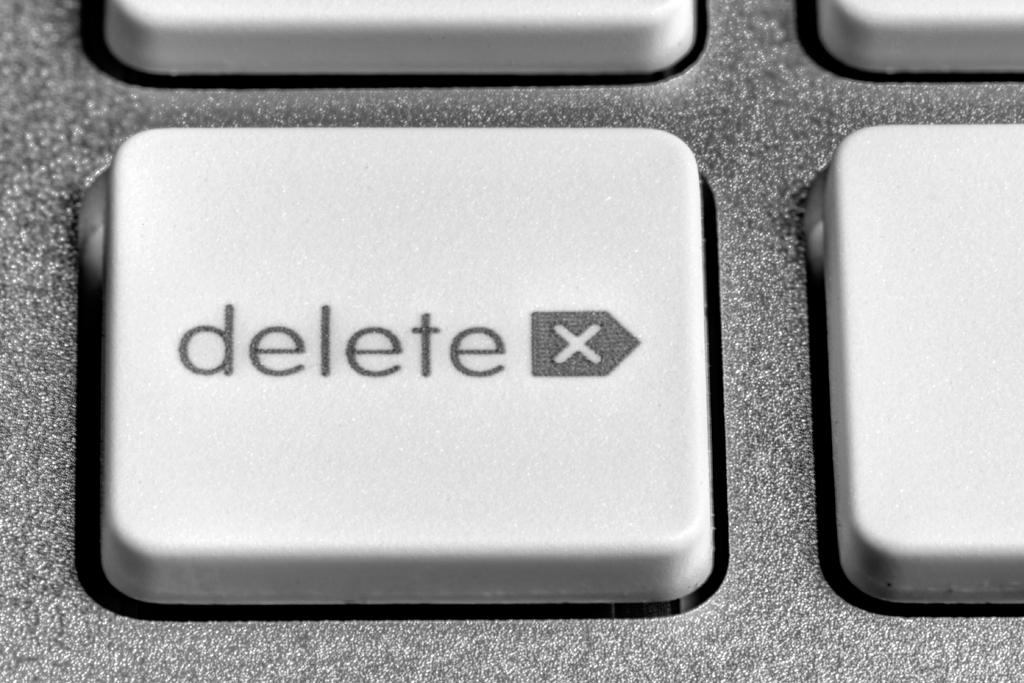Provide a one-sentence caption for the provided image. A close-up of a keyboard shows the delete key. 